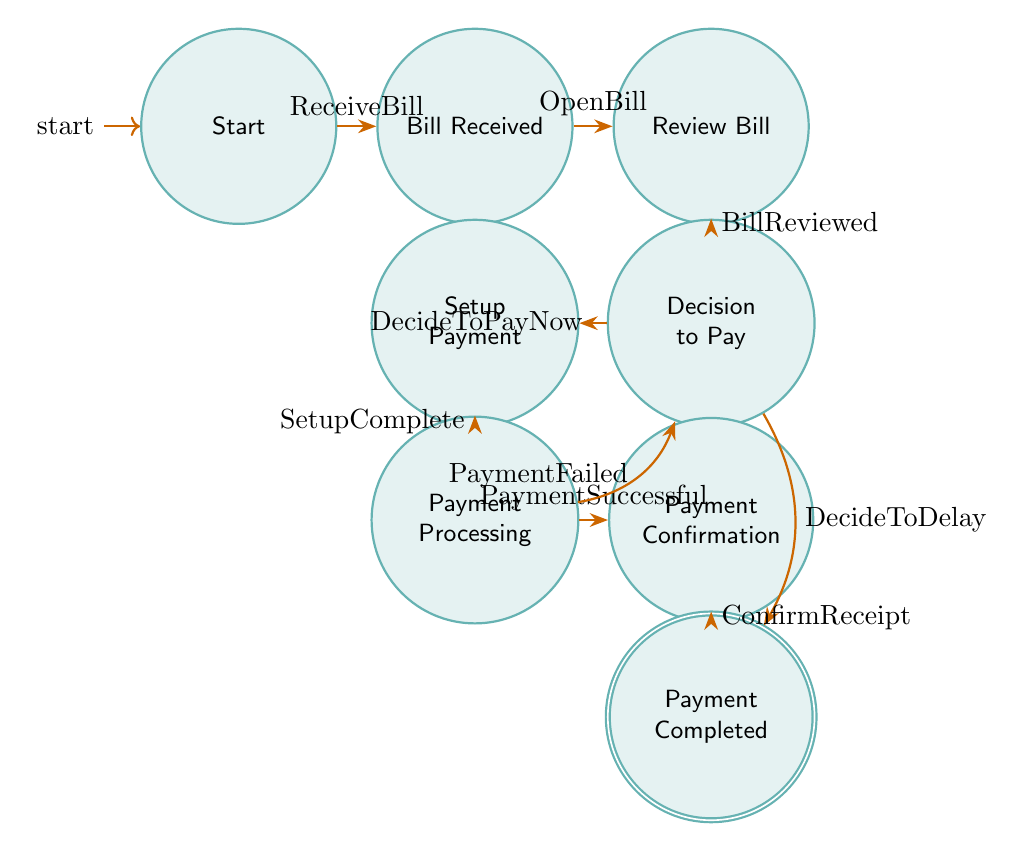What is the starting state of the utility payment process? The starting state is indicated at the beginning of the diagram, labeled as "Start." This node serves as the initial point from which the process begins.
Answer: Start How many states are present in the diagram? By counting the number of individual nodes labeled in the diagram, we find there are a total of eight states: Start, Bill Received, Review Bill, Decision to Pay, Setup Payment, Payment Processing, Payment Confirmation, and Payment Completed.
Answer: Eight What transition occurs after opening the bill? After opening the bill, the transition moves from the "Bill Received" state to the "Review Bill" state. This is indicated in the diagram with the label "OpenBill."
Answer: Review Bill What happens if the payment fails during processing? If the payment fails, the process transitions back to the "Decision to Pay" state, as indicated by the transition labeled "PaymentFailed." This shows that the resident must re-evaluate their decision regarding payment.
Answer: Decision to Pay Which state follows the "Payment Processing" state? After the "Payment Processing" state, the next state is "Payment Confirmation." This is indicated by the transition labeled "PaymentSuccessful," which moves the process forward upon successful completion of payment processing.
Answer: Payment Confirmation How many distinct transitions are present in the diagram? By counting each arrow connecting the states, we see there are a total of eight transitions: ReceiveBill, OpenBill, BillReviewed, DecideToPayNow, DecideToDelay, SetupComplete, PaymentSuccessful, and PaymentFailed.
Answer: Eight What determines whether the payment is processed or delayed? The determination is made during the "Decision to Pay" state, where the resident decides either to pay immediately ("DecideToPayNow") or to delay payment ("DecideToDelay"), indicating a decision-making point in the flow.
Answer: Decision to Pay What does the final state of the process signify? The final state, labeled "Payment Completed," signifies the conclusion of the utility payment process, indicating that all necessary actions regarding the payment have been finalized and no further steps are needed.
Answer: Payment Completed 